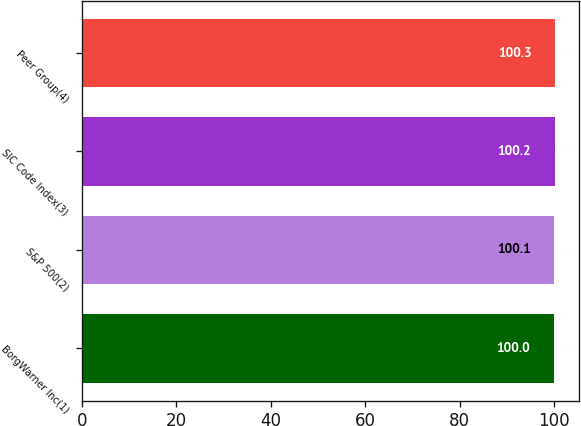<chart> <loc_0><loc_0><loc_500><loc_500><bar_chart><fcel>BorgWarner Inc(1)<fcel>S&P 500(2)<fcel>SIC Code Index(3)<fcel>Peer Group(4)<nl><fcel>100<fcel>100.1<fcel>100.2<fcel>100.3<nl></chart> 